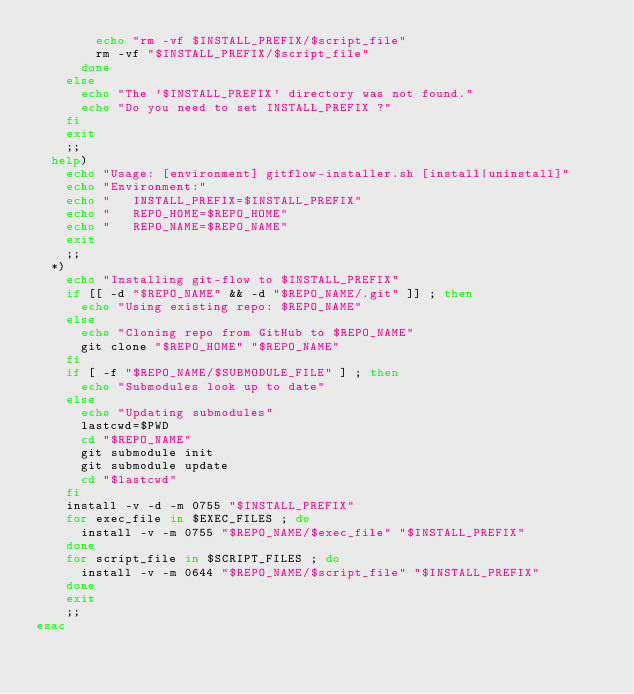<code> <loc_0><loc_0><loc_500><loc_500><_Bash_>				echo "rm -vf $INSTALL_PREFIX/$script_file"
				rm -vf "$INSTALL_PREFIX/$script_file"
			done
		else
			echo "The '$INSTALL_PREFIX' directory was not found."
			echo "Do you need to set INSTALL_PREFIX ?"
		fi
		exit
		;;
	help)
		echo "Usage: [environment] gitflow-installer.sh [install|uninstall]"
		echo "Environment:"
		echo "   INSTALL_PREFIX=$INSTALL_PREFIX"
		echo "   REPO_HOME=$REPO_HOME"
		echo "   REPO_NAME=$REPO_NAME"
		exit
		;;
	*)
		echo "Installing git-flow to $INSTALL_PREFIX"
		if [[ -d "$REPO_NAME" && -d "$REPO_NAME/.git" ]] ; then
			echo "Using existing repo: $REPO_NAME"
		else
			echo "Cloning repo from GitHub to $REPO_NAME"
			git clone "$REPO_HOME" "$REPO_NAME"
		fi
		if [ -f "$REPO_NAME/$SUBMODULE_FILE" ] ; then
			echo "Submodules look up to date"
		else
			echo "Updating submodules"
			lastcwd=$PWD
			cd "$REPO_NAME"
			git submodule init
			git submodule update
			cd "$lastcwd"
		fi
		install -v -d -m 0755 "$INSTALL_PREFIX"
		for exec_file in $EXEC_FILES ; do
			install -v -m 0755 "$REPO_NAME/$exec_file" "$INSTALL_PREFIX"
		done
		for script_file in $SCRIPT_FILES ; do
			install -v -m 0644 "$REPO_NAME/$script_file" "$INSTALL_PREFIX"
		done
		exit
		;;
esac
</code> 